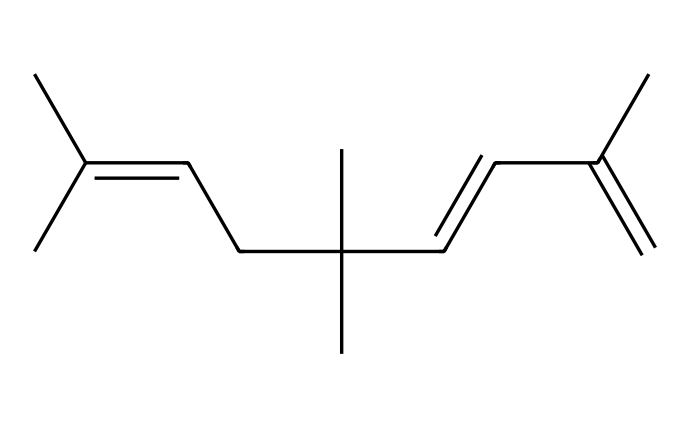What is the total number of carbon atoms in this structure? By examining the SMILES representation, we can count the number of carbon atoms represented. Each "C" indicates a carbon, and by counting all of them in the representation, we find there are 15 carbon atoms.
Answer: 15 How many double bonds are present in this chemical? In the given SMILES, double bonds are indicated by the "=" symbol. Counting the occurrences of this symbol, we find there are three double bonds in the structure.
Answer: 3 What type of chemical compound does this SMILES represent? The structure denotes an aliphatic hydrocarbon due to its long chain of carbon atoms and multiple alkenes (double bonds), which makes it most representative of a type of rubber compound.
Answer: rubber What is the degree of unsaturation in this chemical? To find the degree of unsaturation, we can use the formula: Degree of Unsaturation = (2C + 2 + N - H - X)/2. Here, C (15), H (double carbon count minus double bonds excess), N (0), and X (0 for halogens). This results in a degree of unsaturation of 3, indicated by the three double bonds.
Answer: 3 Which part of this chemical structure contributes to its elasticity? The presence of multiple carbon-carbon double bonds in the structure increases its flexibility and chain length, contributing significantly to the elasticity of rubber compounds.
Answer: double bonds What is the functional group identified in this chemical? The chemical does not have functional groups like hydroxyl or carboxylic acids, but it contains carbon-carbon double bonds, characteristic of alkenes, which influence the chemical's properties.
Answer: alkenes What does the arrangement of branches in this compound indicate about its properties? The branching in the carbon chain often indicates lower densities and higher flexibility, which allows the material to withstand repetitive flexing and heat generated during racing, enhancing performance.
Answer: flexibility 